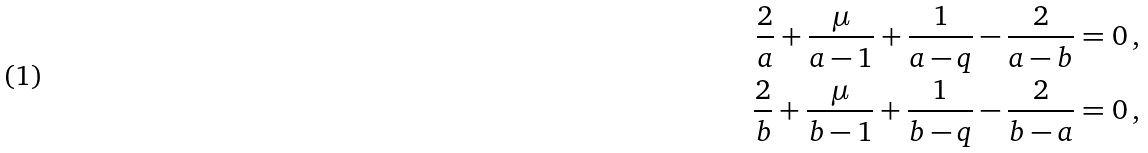Convert formula to latex. <formula><loc_0><loc_0><loc_500><loc_500>\frac { 2 } { a } + \frac { \mu } { a - 1 } + \frac { 1 } { a - q } - \frac { 2 } { a - b } & = 0 \, , \\ \frac { 2 } { b } + \frac { \mu } { b - 1 } + \frac { 1 } { b - q } - \frac { 2 } { b - a } & = 0 \, ,</formula> 